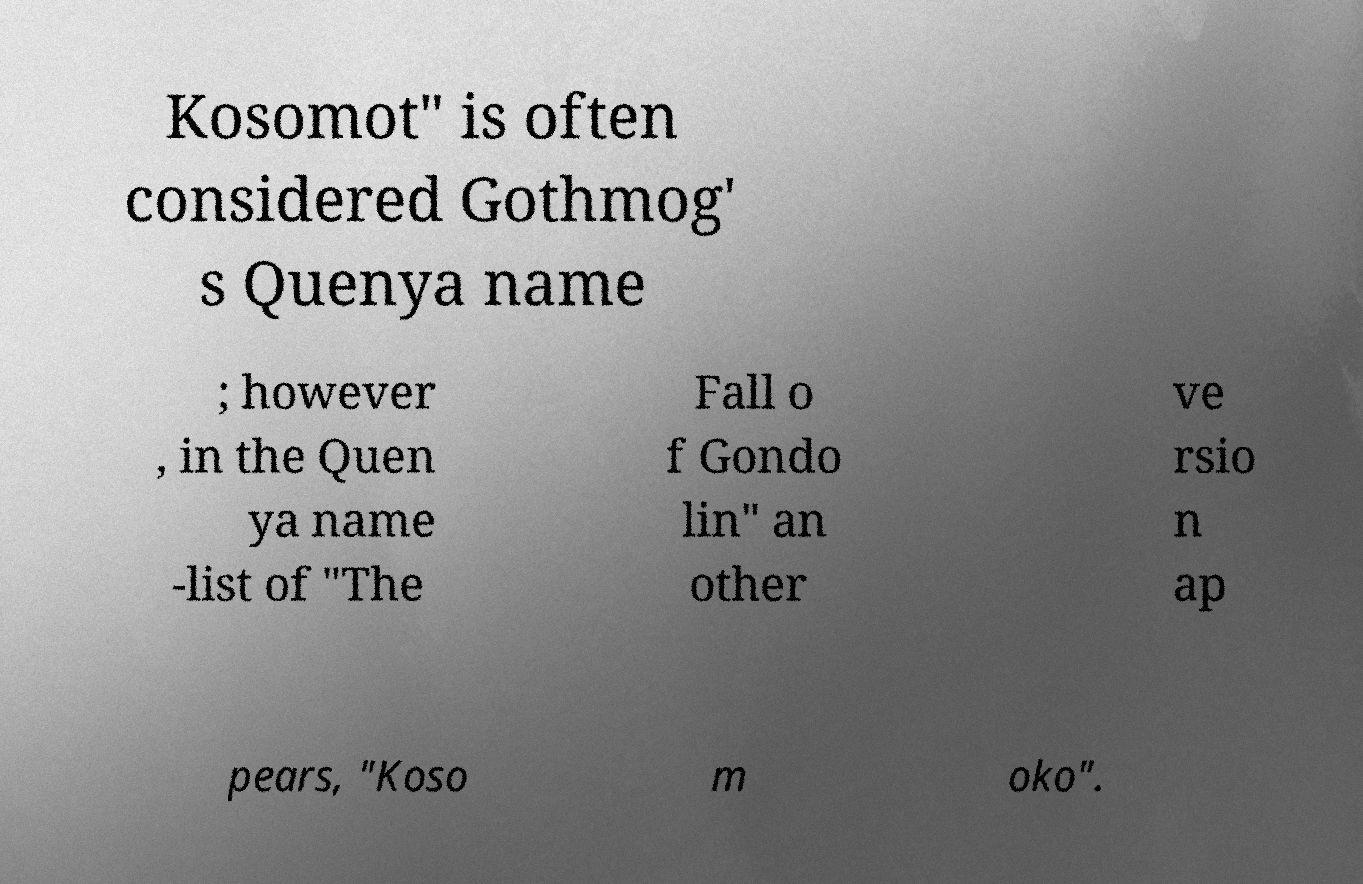Could you assist in decoding the text presented in this image and type it out clearly? Kosomot" is often considered Gothmog' s Quenya name ; however , in the Quen ya name -list of "The Fall o f Gondo lin" an other ve rsio n ap pears, "Koso m oko". 